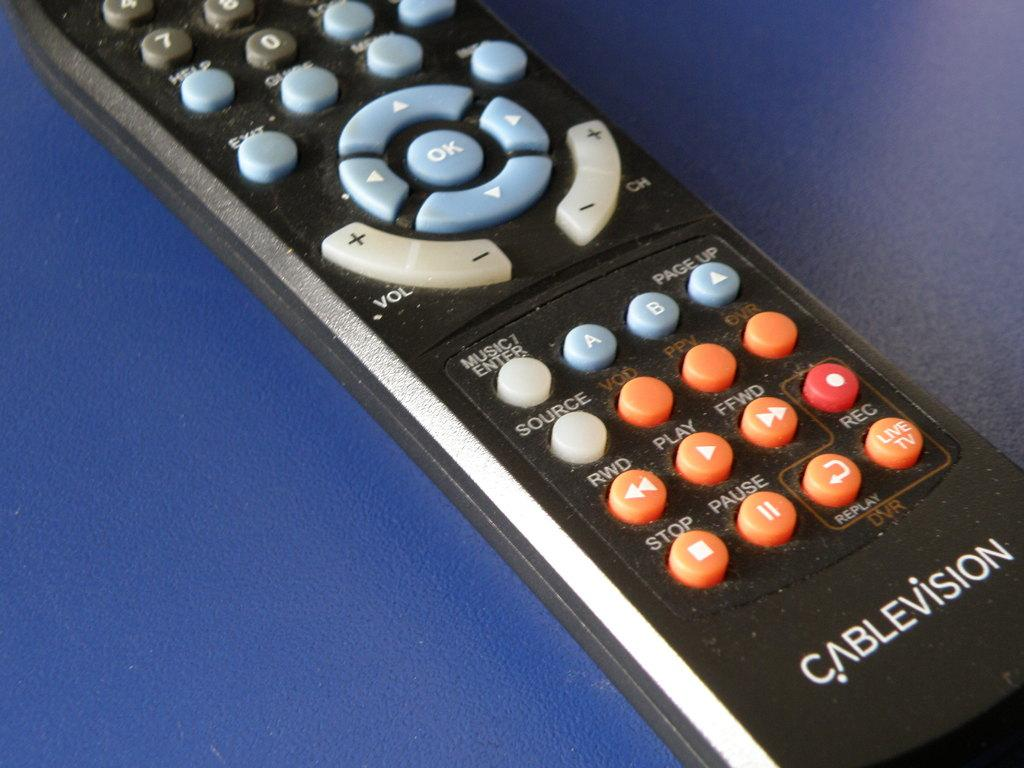Provide a one-sentence caption for the provided image. Cablevision remote that is laying flat and is black with different colors. 